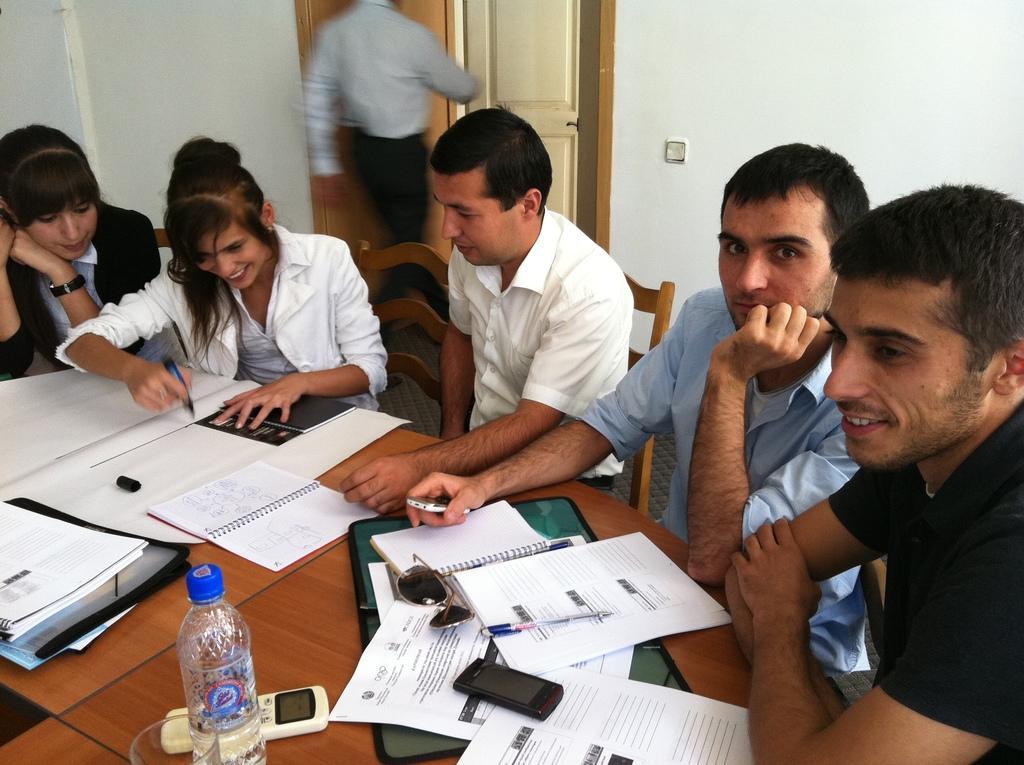In one or two sentences, can you explain what this image depicts? In this image i can see three men are sitting on the chair on the right side and on the left side there are two women sitting on the chair. And on the table we can see a few books and some paper. And we have water bottle and a remote control. Behind the people a man is walking through the door and a white color wall behind the persons. 